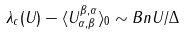Convert formula to latex. <formula><loc_0><loc_0><loc_500><loc_500>\lambda _ { c } ( U ) - \langle U _ { \alpha , \beta } ^ { \beta , \alpha } \rangle _ { 0 } \sim B n U / \Delta</formula> 